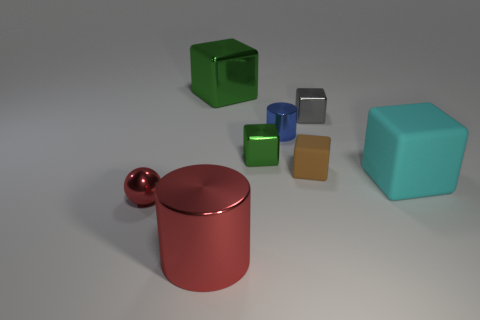What number of other objects are the same shape as the small blue shiny object?
Keep it short and to the point. 1. What is the material of the large thing that is in front of the big green shiny thing and to the left of the cyan matte thing?
Your answer should be very brief. Metal. How many gray metal things are on the left side of the gray metallic thing?
Make the answer very short. 0. How many tiny yellow shiny objects are there?
Your answer should be very brief. 0. Does the brown block have the same size as the red cylinder?
Your answer should be very brief. No. Is there a green shiny block that is left of the large object that is in front of the large cube that is right of the tiny gray cube?
Make the answer very short. No. There is a tiny brown object that is the same shape as the tiny green metallic object; what is it made of?
Offer a very short reply. Rubber. There is a small thing behind the blue cylinder; what color is it?
Provide a succinct answer. Gray. What size is the cyan matte thing?
Make the answer very short. Large. Do the brown matte object and the cylinder in front of the large cyan matte thing have the same size?
Offer a very short reply. No. 